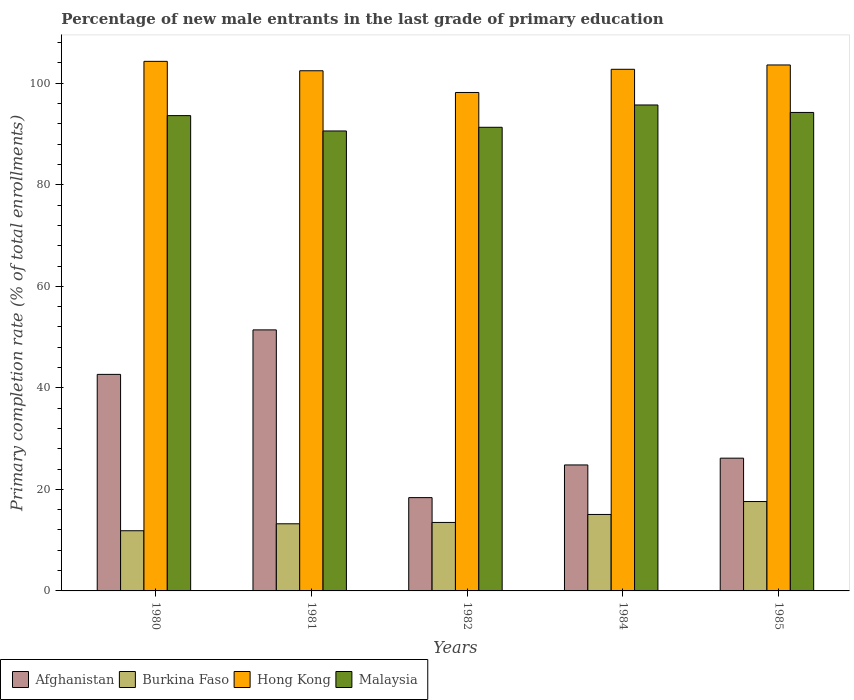How many different coloured bars are there?
Your answer should be compact. 4. Are the number of bars on each tick of the X-axis equal?
Provide a succinct answer. Yes. What is the percentage of new male entrants in Burkina Faso in 1980?
Give a very brief answer. 11.85. Across all years, what is the maximum percentage of new male entrants in Hong Kong?
Your response must be concise. 104.31. Across all years, what is the minimum percentage of new male entrants in Malaysia?
Keep it short and to the point. 90.6. What is the total percentage of new male entrants in Hong Kong in the graph?
Offer a terse response. 511.3. What is the difference between the percentage of new male entrants in Malaysia in 1980 and that in 1985?
Make the answer very short. -0.62. What is the difference between the percentage of new male entrants in Malaysia in 1981 and the percentage of new male entrants in Afghanistan in 1985?
Ensure brevity in your answer.  64.45. What is the average percentage of new male entrants in Afghanistan per year?
Offer a terse response. 32.68. In the year 1982, what is the difference between the percentage of new male entrants in Malaysia and percentage of new male entrants in Burkina Faso?
Your answer should be very brief. 77.84. What is the ratio of the percentage of new male entrants in Malaysia in 1981 to that in 1985?
Ensure brevity in your answer.  0.96. Is the difference between the percentage of new male entrants in Malaysia in 1980 and 1981 greater than the difference between the percentage of new male entrants in Burkina Faso in 1980 and 1981?
Your answer should be compact. Yes. What is the difference between the highest and the second highest percentage of new male entrants in Malaysia?
Your response must be concise. 1.47. What is the difference between the highest and the lowest percentage of new male entrants in Hong Kong?
Provide a succinct answer. 6.13. In how many years, is the percentage of new male entrants in Hong Kong greater than the average percentage of new male entrants in Hong Kong taken over all years?
Give a very brief answer. 4. Is it the case that in every year, the sum of the percentage of new male entrants in Malaysia and percentage of new male entrants in Hong Kong is greater than the sum of percentage of new male entrants in Burkina Faso and percentage of new male entrants in Afghanistan?
Provide a short and direct response. Yes. What does the 3rd bar from the left in 1980 represents?
Ensure brevity in your answer.  Hong Kong. What does the 2nd bar from the right in 1980 represents?
Offer a very short reply. Hong Kong. What is the difference between two consecutive major ticks on the Y-axis?
Ensure brevity in your answer.  20. What is the title of the graph?
Provide a succinct answer. Percentage of new male entrants in the last grade of primary education. Does "Mozambique" appear as one of the legend labels in the graph?
Your response must be concise. No. What is the label or title of the X-axis?
Keep it short and to the point. Years. What is the label or title of the Y-axis?
Give a very brief answer. Primary completion rate (% of total enrollments). What is the Primary completion rate (% of total enrollments) of Afghanistan in 1980?
Provide a succinct answer. 42.65. What is the Primary completion rate (% of total enrollments) in Burkina Faso in 1980?
Provide a short and direct response. 11.85. What is the Primary completion rate (% of total enrollments) of Hong Kong in 1980?
Offer a very short reply. 104.31. What is the Primary completion rate (% of total enrollments) in Malaysia in 1980?
Make the answer very short. 93.62. What is the Primary completion rate (% of total enrollments) of Afghanistan in 1981?
Give a very brief answer. 51.42. What is the Primary completion rate (% of total enrollments) in Burkina Faso in 1981?
Ensure brevity in your answer.  13.22. What is the Primary completion rate (% of total enrollments) of Hong Kong in 1981?
Ensure brevity in your answer.  102.46. What is the Primary completion rate (% of total enrollments) in Malaysia in 1981?
Offer a very short reply. 90.6. What is the Primary completion rate (% of total enrollments) of Afghanistan in 1982?
Give a very brief answer. 18.38. What is the Primary completion rate (% of total enrollments) in Burkina Faso in 1982?
Give a very brief answer. 13.49. What is the Primary completion rate (% of total enrollments) of Hong Kong in 1982?
Ensure brevity in your answer.  98.18. What is the Primary completion rate (% of total enrollments) in Malaysia in 1982?
Ensure brevity in your answer.  91.32. What is the Primary completion rate (% of total enrollments) in Afghanistan in 1984?
Ensure brevity in your answer.  24.81. What is the Primary completion rate (% of total enrollments) of Burkina Faso in 1984?
Your response must be concise. 15.06. What is the Primary completion rate (% of total enrollments) of Hong Kong in 1984?
Your response must be concise. 102.75. What is the Primary completion rate (% of total enrollments) of Malaysia in 1984?
Keep it short and to the point. 95.72. What is the Primary completion rate (% of total enrollments) of Afghanistan in 1985?
Offer a terse response. 26.15. What is the Primary completion rate (% of total enrollments) of Burkina Faso in 1985?
Offer a very short reply. 17.61. What is the Primary completion rate (% of total enrollments) in Hong Kong in 1985?
Your answer should be very brief. 103.6. What is the Primary completion rate (% of total enrollments) in Malaysia in 1985?
Ensure brevity in your answer.  94.25. Across all years, what is the maximum Primary completion rate (% of total enrollments) of Afghanistan?
Offer a very short reply. 51.42. Across all years, what is the maximum Primary completion rate (% of total enrollments) in Burkina Faso?
Your answer should be very brief. 17.61. Across all years, what is the maximum Primary completion rate (% of total enrollments) of Hong Kong?
Offer a very short reply. 104.31. Across all years, what is the maximum Primary completion rate (% of total enrollments) of Malaysia?
Your response must be concise. 95.72. Across all years, what is the minimum Primary completion rate (% of total enrollments) in Afghanistan?
Ensure brevity in your answer.  18.38. Across all years, what is the minimum Primary completion rate (% of total enrollments) in Burkina Faso?
Keep it short and to the point. 11.85. Across all years, what is the minimum Primary completion rate (% of total enrollments) in Hong Kong?
Give a very brief answer. 98.18. Across all years, what is the minimum Primary completion rate (% of total enrollments) in Malaysia?
Ensure brevity in your answer.  90.6. What is the total Primary completion rate (% of total enrollments) in Afghanistan in the graph?
Provide a succinct answer. 163.41. What is the total Primary completion rate (% of total enrollments) in Burkina Faso in the graph?
Provide a succinct answer. 71.24. What is the total Primary completion rate (% of total enrollments) of Hong Kong in the graph?
Your answer should be compact. 511.3. What is the total Primary completion rate (% of total enrollments) in Malaysia in the graph?
Ensure brevity in your answer.  465.51. What is the difference between the Primary completion rate (% of total enrollments) of Afghanistan in 1980 and that in 1981?
Provide a succinct answer. -8.77. What is the difference between the Primary completion rate (% of total enrollments) of Burkina Faso in 1980 and that in 1981?
Offer a terse response. -1.37. What is the difference between the Primary completion rate (% of total enrollments) of Hong Kong in 1980 and that in 1981?
Provide a short and direct response. 1.85. What is the difference between the Primary completion rate (% of total enrollments) in Malaysia in 1980 and that in 1981?
Make the answer very short. 3.02. What is the difference between the Primary completion rate (% of total enrollments) of Afghanistan in 1980 and that in 1982?
Provide a short and direct response. 24.27. What is the difference between the Primary completion rate (% of total enrollments) in Burkina Faso in 1980 and that in 1982?
Your answer should be compact. -1.63. What is the difference between the Primary completion rate (% of total enrollments) in Hong Kong in 1980 and that in 1982?
Provide a succinct answer. 6.13. What is the difference between the Primary completion rate (% of total enrollments) of Malaysia in 1980 and that in 1982?
Your answer should be compact. 2.3. What is the difference between the Primary completion rate (% of total enrollments) in Afghanistan in 1980 and that in 1984?
Offer a very short reply. 17.84. What is the difference between the Primary completion rate (% of total enrollments) in Burkina Faso in 1980 and that in 1984?
Your response must be concise. -3.21. What is the difference between the Primary completion rate (% of total enrollments) of Hong Kong in 1980 and that in 1984?
Your answer should be compact. 1.56. What is the difference between the Primary completion rate (% of total enrollments) in Malaysia in 1980 and that in 1984?
Offer a terse response. -2.1. What is the difference between the Primary completion rate (% of total enrollments) in Afghanistan in 1980 and that in 1985?
Ensure brevity in your answer.  16.5. What is the difference between the Primary completion rate (% of total enrollments) of Burkina Faso in 1980 and that in 1985?
Give a very brief answer. -5.75. What is the difference between the Primary completion rate (% of total enrollments) of Hong Kong in 1980 and that in 1985?
Your answer should be compact. 0.71. What is the difference between the Primary completion rate (% of total enrollments) in Malaysia in 1980 and that in 1985?
Keep it short and to the point. -0.62. What is the difference between the Primary completion rate (% of total enrollments) in Afghanistan in 1981 and that in 1982?
Offer a very short reply. 33.04. What is the difference between the Primary completion rate (% of total enrollments) of Burkina Faso in 1981 and that in 1982?
Keep it short and to the point. -0.26. What is the difference between the Primary completion rate (% of total enrollments) in Hong Kong in 1981 and that in 1982?
Your response must be concise. 4.28. What is the difference between the Primary completion rate (% of total enrollments) of Malaysia in 1981 and that in 1982?
Offer a terse response. -0.73. What is the difference between the Primary completion rate (% of total enrollments) in Afghanistan in 1981 and that in 1984?
Your answer should be very brief. 26.61. What is the difference between the Primary completion rate (% of total enrollments) in Burkina Faso in 1981 and that in 1984?
Ensure brevity in your answer.  -1.84. What is the difference between the Primary completion rate (% of total enrollments) in Hong Kong in 1981 and that in 1984?
Offer a very short reply. -0.29. What is the difference between the Primary completion rate (% of total enrollments) of Malaysia in 1981 and that in 1984?
Give a very brief answer. -5.12. What is the difference between the Primary completion rate (% of total enrollments) in Afghanistan in 1981 and that in 1985?
Ensure brevity in your answer.  25.27. What is the difference between the Primary completion rate (% of total enrollments) of Burkina Faso in 1981 and that in 1985?
Your answer should be compact. -4.38. What is the difference between the Primary completion rate (% of total enrollments) of Hong Kong in 1981 and that in 1985?
Keep it short and to the point. -1.14. What is the difference between the Primary completion rate (% of total enrollments) of Malaysia in 1981 and that in 1985?
Ensure brevity in your answer.  -3.65. What is the difference between the Primary completion rate (% of total enrollments) of Afghanistan in 1982 and that in 1984?
Ensure brevity in your answer.  -6.43. What is the difference between the Primary completion rate (% of total enrollments) of Burkina Faso in 1982 and that in 1984?
Give a very brief answer. -1.57. What is the difference between the Primary completion rate (% of total enrollments) in Hong Kong in 1982 and that in 1984?
Make the answer very short. -4.57. What is the difference between the Primary completion rate (% of total enrollments) of Malaysia in 1982 and that in 1984?
Your answer should be very brief. -4.4. What is the difference between the Primary completion rate (% of total enrollments) of Afghanistan in 1982 and that in 1985?
Provide a succinct answer. -7.77. What is the difference between the Primary completion rate (% of total enrollments) in Burkina Faso in 1982 and that in 1985?
Offer a terse response. -4.12. What is the difference between the Primary completion rate (% of total enrollments) in Hong Kong in 1982 and that in 1985?
Offer a very short reply. -5.42. What is the difference between the Primary completion rate (% of total enrollments) in Malaysia in 1982 and that in 1985?
Your answer should be compact. -2.92. What is the difference between the Primary completion rate (% of total enrollments) of Afghanistan in 1984 and that in 1985?
Ensure brevity in your answer.  -1.34. What is the difference between the Primary completion rate (% of total enrollments) in Burkina Faso in 1984 and that in 1985?
Your response must be concise. -2.55. What is the difference between the Primary completion rate (% of total enrollments) in Hong Kong in 1984 and that in 1985?
Offer a very short reply. -0.85. What is the difference between the Primary completion rate (% of total enrollments) in Malaysia in 1984 and that in 1985?
Your response must be concise. 1.47. What is the difference between the Primary completion rate (% of total enrollments) of Afghanistan in 1980 and the Primary completion rate (% of total enrollments) of Burkina Faso in 1981?
Offer a very short reply. 29.43. What is the difference between the Primary completion rate (% of total enrollments) in Afghanistan in 1980 and the Primary completion rate (% of total enrollments) in Hong Kong in 1981?
Provide a succinct answer. -59.81. What is the difference between the Primary completion rate (% of total enrollments) in Afghanistan in 1980 and the Primary completion rate (% of total enrollments) in Malaysia in 1981?
Keep it short and to the point. -47.95. What is the difference between the Primary completion rate (% of total enrollments) of Burkina Faso in 1980 and the Primary completion rate (% of total enrollments) of Hong Kong in 1981?
Keep it short and to the point. -90.6. What is the difference between the Primary completion rate (% of total enrollments) of Burkina Faso in 1980 and the Primary completion rate (% of total enrollments) of Malaysia in 1981?
Your answer should be very brief. -78.74. What is the difference between the Primary completion rate (% of total enrollments) of Hong Kong in 1980 and the Primary completion rate (% of total enrollments) of Malaysia in 1981?
Your response must be concise. 13.71. What is the difference between the Primary completion rate (% of total enrollments) of Afghanistan in 1980 and the Primary completion rate (% of total enrollments) of Burkina Faso in 1982?
Your answer should be compact. 29.16. What is the difference between the Primary completion rate (% of total enrollments) of Afghanistan in 1980 and the Primary completion rate (% of total enrollments) of Hong Kong in 1982?
Make the answer very short. -55.53. What is the difference between the Primary completion rate (% of total enrollments) in Afghanistan in 1980 and the Primary completion rate (% of total enrollments) in Malaysia in 1982?
Provide a succinct answer. -48.67. What is the difference between the Primary completion rate (% of total enrollments) of Burkina Faso in 1980 and the Primary completion rate (% of total enrollments) of Hong Kong in 1982?
Provide a succinct answer. -86.33. What is the difference between the Primary completion rate (% of total enrollments) in Burkina Faso in 1980 and the Primary completion rate (% of total enrollments) in Malaysia in 1982?
Keep it short and to the point. -79.47. What is the difference between the Primary completion rate (% of total enrollments) of Hong Kong in 1980 and the Primary completion rate (% of total enrollments) of Malaysia in 1982?
Offer a very short reply. 12.99. What is the difference between the Primary completion rate (% of total enrollments) in Afghanistan in 1980 and the Primary completion rate (% of total enrollments) in Burkina Faso in 1984?
Give a very brief answer. 27.59. What is the difference between the Primary completion rate (% of total enrollments) of Afghanistan in 1980 and the Primary completion rate (% of total enrollments) of Hong Kong in 1984?
Provide a short and direct response. -60.1. What is the difference between the Primary completion rate (% of total enrollments) of Afghanistan in 1980 and the Primary completion rate (% of total enrollments) of Malaysia in 1984?
Provide a succinct answer. -53.07. What is the difference between the Primary completion rate (% of total enrollments) of Burkina Faso in 1980 and the Primary completion rate (% of total enrollments) of Hong Kong in 1984?
Provide a succinct answer. -90.89. What is the difference between the Primary completion rate (% of total enrollments) of Burkina Faso in 1980 and the Primary completion rate (% of total enrollments) of Malaysia in 1984?
Provide a short and direct response. -83.87. What is the difference between the Primary completion rate (% of total enrollments) of Hong Kong in 1980 and the Primary completion rate (% of total enrollments) of Malaysia in 1984?
Your response must be concise. 8.59. What is the difference between the Primary completion rate (% of total enrollments) of Afghanistan in 1980 and the Primary completion rate (% of total enrollments) of Burkina Faso in 1985?
Make the answer very short. 25.04. What is the difference between the Primary completion rate (% of total enrollments) of Afghanistan in 1980 and the Primary completion rate (% of total enrollments) of Hong Kong in 1985?
Your response must be concise. -60.95. What is the difference between the Primary completion rate (% of total enrollments) of Afghanistan in 1980 and the Primary completion rate (% of total enrollments) of Malaysia in 1985?
Make the answer very short. -51.59. What is the difference between the Primary completion rate (% of total enrollments) of Burkina Faso in 1980 and the Primary completion rate (% of total enrollments) of Hong Kong in 1985?
Provide a succinct answer. -91.75. What is the difference between the Primary completion rate (% of total enrollments) of Burkina Faso in 1980 and the Primary completion rate (% of total enrollments) of Malaysia in 1985?
Ensure brevity in your answer.  -82.39. What is the difference between the Primary completion rate (% of total enrollments) of Hong Kong in 1980 and the Primary completion rate (% of total enrollments) of Malaysia in 1985?
Your answer should be very brief. 10.06. What is the difference between the Primary completion rate (% of total enrollments) of Afghanistan in 1981 and the Primary completion rate (% of total enrollments) of Burkina Faso in 1982?
Give a very brief answer. 37.93. What is the difference between the Primary completion rate (% of total enrollments) in Afghanistan in 1981 and the Primary completion rate (% of total enrollments) in Hong Kong in 1982?
Give a very brief answer. -46.76. What is the difference between the Primary completion rate (% of total enrollments) of Afghanistan in 1981 and the Primary completion rate (% of total enrollments) of Malaysia in 1982?
Provide a succinct answer. -39.91. What is the difference between the Primary completion rate (% of total enrollments) in Burkina Faso in 1981 and the Primary completion rate (% of total enrollments) in Hong Kong in 1982?
Ensure brevity in your answer.  -84.96. What is the difference between the Primary completion rate (% of total enrollments) in Burkina Faso in 1981 and the Primary completion rate (% of total enrollments) in Malaysia in 1982?
Provide a short and direct response. -78.1. What is the difference between the Primary completion rate (% of total enrollments) in Hong Kong in 1981 and the Primary completion rate (% of total enrollments) in Malaysia in 1982?
Offer a very short reply. 11.13. What is the difference between the Primary completion rate (% of total enrollments) in Afghanistan in 1981 and the Primary completion rate (% of total enrollments) in Burkina Faso in 1984?
Offer a terse response. 36.36. What is the difference between the Primary completion rate (% of total enrollments) of Afghanistan in 1981 and the Primary completion rate (% of total enrollments) of Hong Kong in 1984?
Your answer should be compact. -51.33. What is the difference between the Primary completion rate (% of total enrollments) of Afghanistan in 1981 and the Primary completion rate (% of total enrollments) of Malaysia in 1984?
Offer a terse response. -44.3. What is the difference between the Primary completion rate (% of total enrollments) of Burkina Faso in 1981 and the Primary completion rate (% of total enrollments) of Hong Kong in 1984?
Keep it short and to the point. -89.53. What is the difference between the Primary completion rate (% of total enrollments) of Burkina Faso in 1981 and the Primary completion rate (% of total enrollments) of Malaysia in 1984?
Make the answer very short. -82.5. What is the difference between the Primary completion rate (% of total enrollments) of Hong Kong in 1981 and the Primary completion rate (% of total enrollments) of Malaysia in 1984?
Make the answer very short. 6.74. What is the difference between the Primary completion rate (% of total enrollments) of Afghanistan in 1981 and the Primary completion rate (% of total enrollments) of Burkina Faso in 1985?
Keep it short and to the point. 33.81. What is the difference between the Primary completion rate (% of total enrollments) of Afghanistan in 1981 and the Primary completion rate (% of total enrollments) of Hong Kong in 1985?
Make the answer very short. -52.18. What is the difference between the Primary completion rate (% of total enrollments) in Afghanistan in 1981 and the Primary completion rate (% of total enrollments) in Malaysia in 1985?
Give a very brief answer. -42.83. What is the difference between the Primary completion rate (% of total enrollments) of Burkina Faso in 1981 and the Primary completion rate (% of total enrollments) of Hong Kong in 1985?
Make the answer very short. -90.38. What is the difference between the Primary completion rate (% of total enrollments) of Burkina Faso in 1981 and the Primary completion rate (% of total enrollments) of Malaysia in 1985?
Offer a terse response. -81.02. What is the difference between the Primary completion rate (% of total enrollments) in Hong Kong in 1981 and the Primary completion rate (% of total enrollments) in Malaysia in 1985?
Offer a terse response. 8.21. What is the difference between the Primary completion rate (% of total enrollments) in Afghanistan in 1982 and the Primary completion rate (% of total enrollments) in Burkina Faso in 1984?
Your answer should be compact. 3.32. What is the difference between the Primary completion rate (% of total enrollments) of Afghanistan in 1982 and the Primary completion rate (% of total enrollments) of Hong Kong in 1984?
Your answer should be very brief. -84.37. What is the difference between the Primary completion rate (% of total enrollments) of Afghanistan in 1982 and the Primary completion rate (% of total enrollments) of Malaysia in 1984?
Provide a succinct answer. -77.34. What is the difference between the Primary completion rate (% of total enrollments) in Burkina Faso in 1982 and the Primary completion rate (% of total enrollments) in Hong Kong in 1984?
Your answer should be very brief. -89.26. What is the difference between the Primary completion rate (% of total enrollments) of Burkina Faso in 1982 and the Primary completion rate (% of total enrollments) of Malaysia in 1984?
Keep it short and to the point. -82.23. What is the difference between the Primary completion rate (% of total enrollments) in Hong Kong in 1982 and the Primary completion rate (% of total enrollments) in Malaysia in 1984?
Provide a succinct answer. 2.46. What is the difference between the Primary completion rate (% of total enrollments) of Afghanistan in 1982 and the Primary completion rate (% of total enrollments) of Burkina Faso in 1985?
Offer a very short reply. 0.77. What is the difference between the Primary completion rate (% of total enrollments) in Afghanistan in 1982 and the Primary completion rate (% of total enrollments) in Hong Kong in 1985?
Your response must be concise. -85.22. What is the difference between the Primary completion rate (% of total enrollments) in Afghanistan in 1982 and the Primary completion rate (% of total enrollments) in Malaysia in 1985?
Ensure brevity in your answer.  -75.87. What is the difference between the Primary completion rate (% of total enrollments) in Burkina Faso in 1982 and the Primary completion rate (% of total enrollments) in Hong Kong in 1985?
Make the answer very short. -90.11. What is the difference between the Primary completion rate (% of total enrollments) of Burkina Faso in 1982 and the Primary completion rate (% of total enrollments) of Malaysia in 1985?
Give a very brief answer. -80.76. What is the difference between the Primary completion rate (% of total enrollments) of Hong Kong in 1982 and the Primary completion rate (% of total enrollments) of Malaysia in 1985?
Make the answer very short. 3.93. What is the difference between the Primary completion rate (% of total enrollments) in Afghanistan in 1984 and the Primary completion rate (% of total enrollments) in Burkina Faso in 1985?
Make the answer very short. 7.21. What is the difference between the Primary completion rate (% of total enrollments) in Afghanistan in 1984 and the Primary completion rate (% of total enrollments) in Hong Kong in 1985?
Your answer should be compact. -78.79. What is the difference between the Primary completion rate (% of total enrollments) in Afghanistan in 1984 and the Primary completion rate (% of total enrollments) in Malaysia in 1985?
Keep it short and to the point. -69.43. What is the difference between the Primary completion rate (% of total enrollments) in Burkina Faso in 1984 and the Primary completion rate (% of total enrollments) in Hong Kong in 1985?
Provide a short and direct response. -88.54. What is the difference between the Primary completion rate (% of total enrollments) of Burkina Faso in 1984 and the Primary completion rate (% of total enrollments) of Malaysia in 1985?
Provide a short and direct response. -79.19. What is the difference between the Primary completion rate (% of total enrollments) in Hong Kong in 1984 and the Primary completion rate (% of total enrollments) in Malaysia in 1985?
Offer a very short reply. 8.5. What is the average Primary completion rate (% of total enrollments) of Afghanistan per year?
Ensure brevity in your answer.  32.68. What is the average Primary completion rate (% of total enrollments) in Burkina Faso per year?
Offer a terse response. 14.25. What is the average Primary completion rate (% of total enrollments) of Hong Kong per year?
Your response must be concise. 102.26. What is the average Primary completion rate (% of total enrollments) in Malaysia per year?
Offer a terse response. 93.1. In the year 1980, what is the difference between the Primary completion rate (% of total enrollments) in Afghanistan and Primary completion rate (% of total enrollments) in Burkina Faso?
Ensure brevity in your answer.  30.8. In the year 1980, what is the difference between the Primary completion rate (% of total enrollments) in Afghanistan and Primary completion rate (% of total enrollments) in Hong Kong?
Give a very brief answer. -61.66. In the year 1980, what is the difference between the Primary completion rate (% of total enrollments) of Afghanistan and Primary completion rate (% of total enrollments) of Malaysia?
Offer a very short reply. -50.97. In the year 1980, what is the difference between the Primary completion rate (% of total enrollments) of Burkina Faso and Primary completion rate (% of total enrollments) of Hong Kong?
Ensure brevity in your answer.  -92.46. In the year 1980, what is the difference between the Primary completion rate (% of total enrollments) in Burkina Faso and Primary completion rate (% of total enrollments) in Malaysia?
Give a very brief answer. -81.77. In the year 1980, what is the difference between the Primary completion rate (% of total enrollments) in Hong Kong and Primary completion rate (% of total enrollments) in Malaysia?
Your response must be concise. 10.69. In the year 1981, what is the difference between the Primary completion rate (% of total enrollments) in Afghanistan and Primary completion rate (% of total enrollments) in Burkina Faso?
Make the answer very short. 38.19. In the year 1981, what is the difference between the Primary completion rate (% of total enrollments) of Afghanistan and Primary completion rate (% of total enrollments) of Hong Kong?
Provide a short and direct response. -51.04. In the year 1981, what is the difference between the Primary completion rate (% of total enrollments) of Afghanistan and Primary completion rate (% of total enrollments) of Malaysia?
Provide a short and direct response. -39.18. In the year 1981, what is the difference between the Primary completion rate (% of total enrollments) of Burkina Faso and Primary completion rate (% of total enrollments) of Hong Kong?
Offer a terse response. -89.23. In the year 1981, what is the difference between the Primary completion rate (% of total enrollments) of Burkina Faso and Primary completion rate (% of total enrollments) of Malaysia?
Provide a short and direct response. -77.37. In the year 1981, what is the difference between the Primary completion rate (% of total enrollments) of Hong Kong and Primary completion rate (% of total enrollments) of Malaysia?
Provide a short and direct response. 11.86. In the year 1982, what is the difference between the Primary completion rate (% of total enrollments) of Afghanistan and Primary completion rate (% of total enrollments) of Burkina Faso?
Keep it short and to the point. 4.89. In the year 1982, what is the difference between the Primary completion rate (% of total enrollments) in Afghanistan and Primary completion rate (% of total enrollments) in Hong Kong?
Offer a very short reply. -79.8. In the year 1982, what is the difference between the Primary completion rate (% of total enrollments) of Afghanistan and Primary completion rate (% of total enrollments) of Malaysia?
Make the answer very short. -72.95. In the year 1982, what is the difference between the Primary completion rate (% of total enrollments) in Burkina Faso and Primary completion rate (% of total enrollments) in Hong Kong?
Provide a succinct answer. -84.69. In the year 1982, what is the difference between the Primary completion rate (% of total enrollments) in Burkina Faso and Primary completion rate (% of total enrollments) in Malaysia?
Ensure brevity in your answer.  -77.84. In the year 1982, what is the difference between the Primary completion rate (% of total enrollments) in Hong Kong and Primary completion rate (% of total enrollments) in Malaysia?
Make the answer very short. 6.86. In the year 1984, what is the difference between the Primary completion rate (% of total enrollments) in Afghanistan and Primary completion rate (% of total enrollments) in Burkina Faso?
Offer a terse response. 9.75. In the year 1984, what is the difference between the Primary completion rate (% of total enrollments) in Afghanistan and Primary completion rate (% of total enrollments) in Hong Kong?
Provide a short and direct response. -77.94. In the year 1984, what is the difference between the Primary completion rate (% of total enrollments) in Afghanistan and Primary completion rate (% of total enrollments) in Malaysia?
Make the answer very short. -70.91. In the year 1984, what is the difference between the Primary completion rate (% of total enrollments) in Burkina Faso and Primary completion rate (% of total enrollments) in Hong Kong?
Provide a succinct answer. -87.69. In the year 1984, what is the difference between the Primary completion rate (% of total enrollments) of Burkina Faso and Primary completion rate (% of total enrollments) of Malaysia?
Keep it short and to the point. -80.66. In the year 1984, what is the difference between the Primary completion rate (% of total enrollments) in Hong Kong and Primary completion rate (% of total enrollments) in Malaysia?
Keep it short and to the point. 7.03. In the year 1985, what is the difference between the Primary completion rate (% of total enrollments) of Afghanistan and Primary completion rate (% of total enrollments) of Burkina Faso?
Ensure brevity in your answer.  8.54. In the year 1985, what is the difference between the Primary completion rate (% of total enrollments) in Afghanistan and Primary completion rate (% of total enrollments) in Hong Kong?
Provide a succinct answer. -77.45. In the year 1985, what is the difference between the Primary completion rate (% of total enrollments) in Afghanistan and Primary completion rate (% of total enrollments) in Malaysia?
Offer a very short reply. -68.1. In the year 1985, what is the difference between the Primary completion rate (% of total enrollments) in Burkina Faso and Primary completion rate (% of total enrollments) in Hong Kong?
Provide a short and direct response. -85.99. In the year 1985, what is the difference between the Primary completion rate (% of total enrollments) of Burkina Faso and Primary completion rate (% of total enrollments) of Malaysia?
Offer a terse response. -76.64. In the year 1985, what is the difference between the Primary completion rate (% of total enrollments) of Hong Kong and Primary completion rate (% of total enrollments) of Malaysia?
Keep it short and to the point. 9.35. What is the ratio of the Primary completion rate (% of total enrollments) in Afghanistan in 1980 to that in 1981?
Provide a succinct answer. 0.83. What is the ratio of the Primary completion rate (% of total enrollments) of Burkina Faso in 1980 to that in 1981?
Make the answer very short. 0.9. What is the ratio of the Primary completion rate (% of total enrollments) of Hong Kong in 1980 to that in 1981?
Make the answer very short. 1.02. What is the ratio of the Primary completion rate (% of total enrollments) of Malaysia in 1980 to that in 1981?
Your answer should be very brief. 1.03. What is the ratio of the Primary completion rate (% of total enrollments) in Afghanistan in 1980 to that in 1982?
Keep it short and to the point. 2.32. What is the ratio of the Primary completion rate (% of total enrollments) in Burkina Faso in 1980 to that in 1982?
Provide a short and direct response. 0.88. What is the ratio of the Primary completion rate (% of total enrollments) in Hong Kong in 1980 to that in 1982?
Make the answer very short. 1.06. What is the ratio of the Primary completion rate (% of total enrollments) in Malaysia in 1980 to that in 1982?
Make the answer very short. 1.03. What is the ratio of the Primary completion rate (% of total enrollments) in Afghanistan in 1980 to that in 1984?
Ensure brevity in your answer.  1.72. What is the ratio of the Primary completion rate (% of total enrollments) in Burkina Faso in 1980 to that in 1984?
Offer a terse response. 0.79. What is the ratio of the Primary completion rate (% of total enrollments) in Hong Kong in 1980 to that in 1984?
Offer a terse response. 1.02. What is the ratio of the Primary completion rate (% of total enrollments) of Malaysia in 1980 to that in 1984?
Your response must be concise. 0.98. What is the ratio of the Primary completion rate (% of total enrollments) of Afghanistan in 1980 to that in 1985?
Give a very brief answer. 1.63. What is the ratio of the Primary completion rate (% of total enrollments) in Burkina Faso in 1980 to that in 1985?
Make the answer very short. 0.67. What is the ratio of the Primary completion rate (% of total enrollments) of Malaysia in 1980 to that in 1985?
Offer a terse response. 0.99. What is the ratio of the Primary completion rate (% of total enrollments) in Afghanistan in 1981 to that in 1982?
Provide a succinct answer. 2.8. What is the ratio of the Primary completion rate (% of total enrollments) of Burkina Faso in 1981 to that in 1982?
Offer a terse response. 0.98. What is the ratio of the Primary completion rate (% of total enrollments) of Hong Kong in 1981 to that in 1982?
Provide a succinct answer. 1.04. What is the ratio of the Primary completion rate (% of total enrollments) in Malaysia in 1981 to that in 1982?
Ensure brevity in your answer.  0.99. What is the ratio of the Primary completion rate (% of total enrollments) in Afghanistan in 1981 to that in 1984?
Ensure brevity in your answer.  2.07. What is the ratio of the Primary completion rate (% of total enrollments) in Burkina Faso in 1981 to that in 1984?
Keep it short and to the point. 0.88. What is the ratio of the Primary completion rate (% of total enrollments) in Hong Kong in 1981 to that in 1984?
Provide a short and direct response. 1. What is the ratio of the Primary completion rate (% of total enrollments) of Malaysia in 1981 to that in 1984?
Make the answer very short. 0.95. What is the ratio of the Primary completion rate (% of total enrollments) of Afghanistan in 1981 to that in 1985?
Your answer should be very brief. 1.97. What is the ratio of the Primary completion rate (% of total enrollments) in Burkina Faso in 1981 to that in 1985?
Make the answer very short. 0.75. What is the ratio of the Primary completion rate (% of total enrollments) of Malaysia in 1981 to that in 1985?
Your response must be concise. 0.96. What is the ratio of the Primary completion rate (% of total enrollments) of Afghanistan in 1982 to that in 1984?
Give a very brief answer. 0.74. What is the ratio of the Primary completion rate (% of total enrollments) in Burkina Faso in 1982 to that in 1984?
Keep it short and to the point. 0.9. What is the ratio of the Primary completion rate (% of total enrollments) in Hong Kong in 1982 to that in 1984?
Offer a terse response. 0.96. What is the ratio of the Primary completion rate (% of total enrollments) in Malaysia in 1982 to that in 1984?
Provide a short and direct response. 0.95. What is the ratio of the Primary completion rate (% of total enrollments) in Afghanistan in 1982 to that in 1985?
Provide a short and direct response. 0.7. What is the ratio of the Primary completion rate (% of total enrollments) of Burkina Faso in 1982 to that in 1985?
Your answer should be very brief. 0.77. What is the ratio of the Primary completion rate (% of total enrollments) in Hong Kong in 1982 to that in 1985?
Your answer should be compact. 0.95. What is the ratio of the Primary completion rate (% of total enrollments) of Malaysia in 1982 to that in 1985?
Ensure brevity in your answer.  0.97. What is the ratio of the Primary completion rate (% of total enrollments) of Afghanistan in 1984 to that in 1985?
Offer a terse response. 0.95. What is the ratio of the Primary completion rate (% of total enrollments) in Burkina Faso in 1984 to that in 1985?
Ensure brevity in your answer.  0.86. What is the ratio of the Primary completion rate (% of total enrollments) of Hong Kong in 1984 to that in 1985?
Offer a very short reply. 0.99. What is the ratio of the Primary completion rate (% of total enrollments) of Malaysia in 1984 to that in 1985?
Keep it short and to the point. 1.02. What is the difference between the highest and the second highest Primary completion rate (% of total enrollments) of Afghanistan?
Provide a short and direct response. 8.77. What is the difference between the highest and the second highest Primary completion rate (% of total enrollments) of Burkina Faso?
Provide a short and direct response. 2.55. What is the difference between the highest and the second highest Primary completion rate (% of total enrollments) in Hong Kong?
Give a very brief answer. 0.71. What is the difference between the highest and the second highest Primary completion rate (% of total enrollments) in Malaysia?
Provide a succinct answer. 1.47. What is the difference between the highest and the lowest Primary completion rate (% of total enrollments) in Afghanistan?
Provide a short and direct response. 33.04. What is the difference between the highest and the lowest Primary completion rate (% of total enrollments) in Burkina Faso?
Offer a terse response. 5.75. What is the difference between the highest and the lowest Primary completion rate (% of total enrollments) of Hong Kong?
Your answer should be very brief. 6.13. What is the difference between the highest and the lowest Primary completion rate (% of total enrollments) of Malaysia?
Keep it short and to the point. 5.12. 